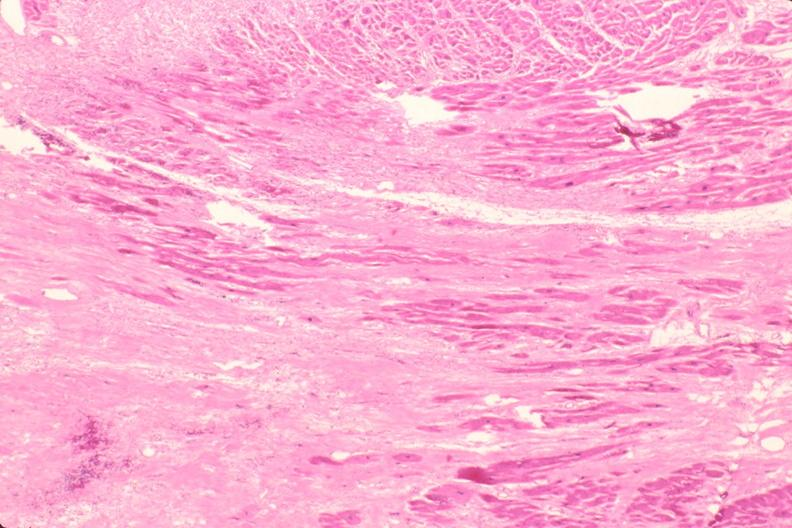does this image show heart, fibrosis, chronic rheumatic heart disease?
Answer the question using a single word or phrase. Yes 